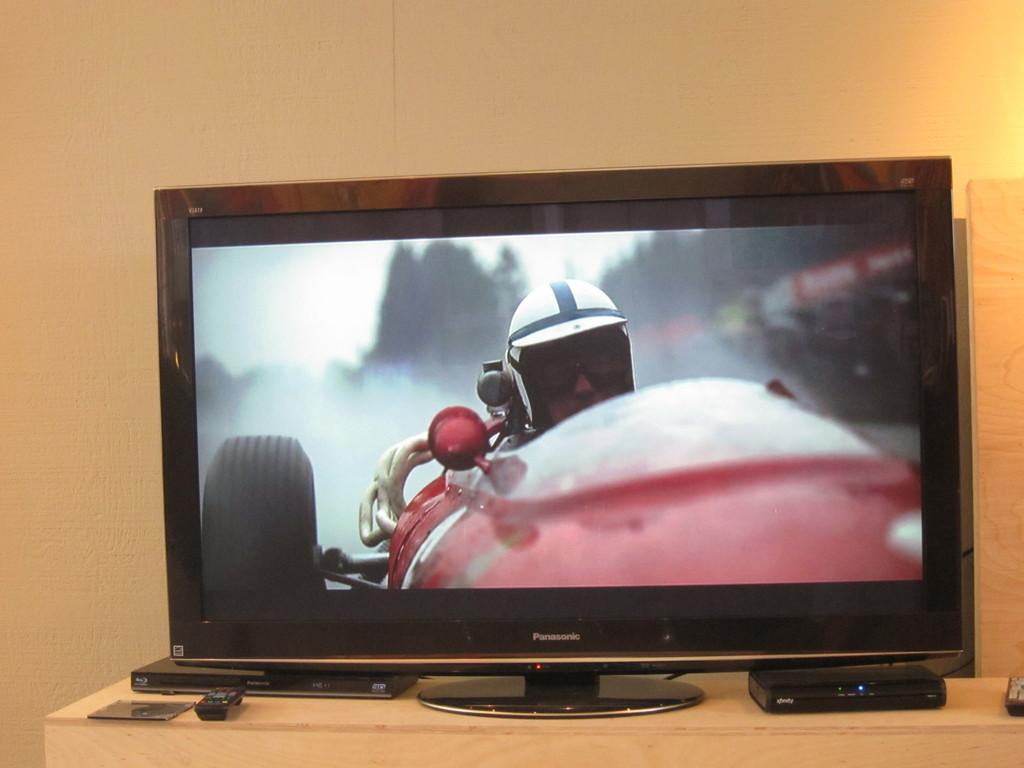<image>
Present a compact description of the photo's key features. A Panasonic monitor shows a person in a race car. 